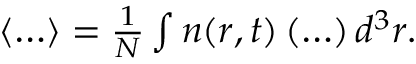<formula> <loc_0><loc_0><loc_500><loc_500>\begin{array} { r } { \langle \dots \rangle = \frac { 1 } { N } \int n ( r , t ) \left ( \dots \right ) d ^ { 3 } r . } \end{array}</formula> 